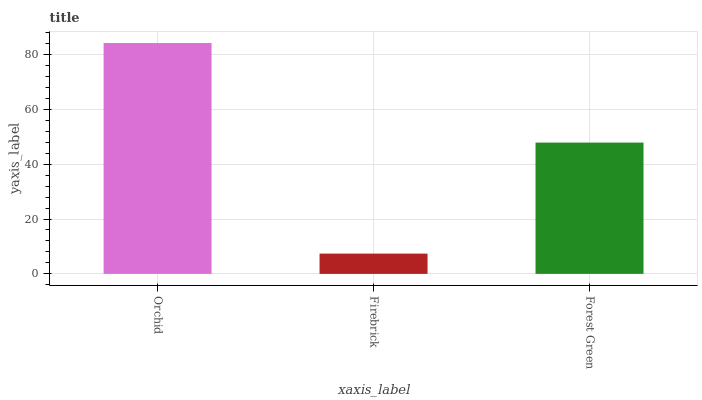Is Firebrick the minimum?
Answer yes or no. Yes. Is Orchid the maximum?
Answer yes or no. Yes. Is Forest Green the minimum?
Answer yes or no. No. Is Forest Green the maximum?
Answer yes or no. No. Is Forest Green greater than Firebrick?
Answer yes or no. Yes. Is Firebrick less than Forest Green?
Answer yes or no. Yes. Is Firebrick greater than Forest Green?
Answer yes or no. No. Is Forest Green less than Firebrick?
Answer yes or no. No. Is Forest Green the high median?
Answer yes or no. Yes. Is Forest Green the low median?
Answer yes or no. Yes. Is Orchid the high median?
Answer yes or no. No. Is Orchid the low median?
Answer yes or no. No. 